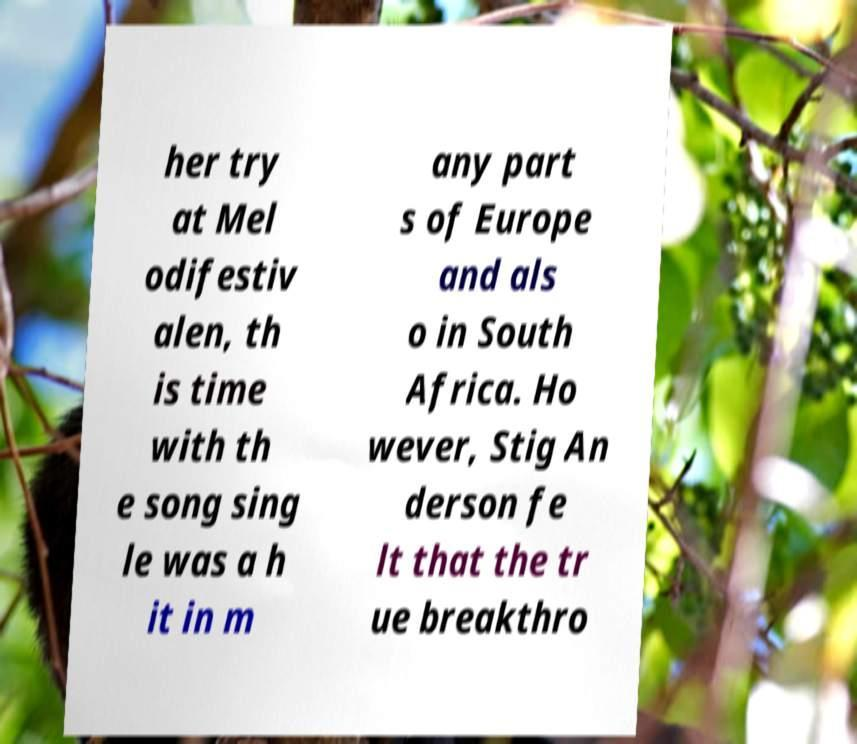Could you extract and type out the text from this image? her try at Mel odifestiv alen, th is time with th e song sing le was a h it in m any part s of Europe and als o in South Africa. Ho wever, Stig An derson fe lt that the tr ue breakthro 